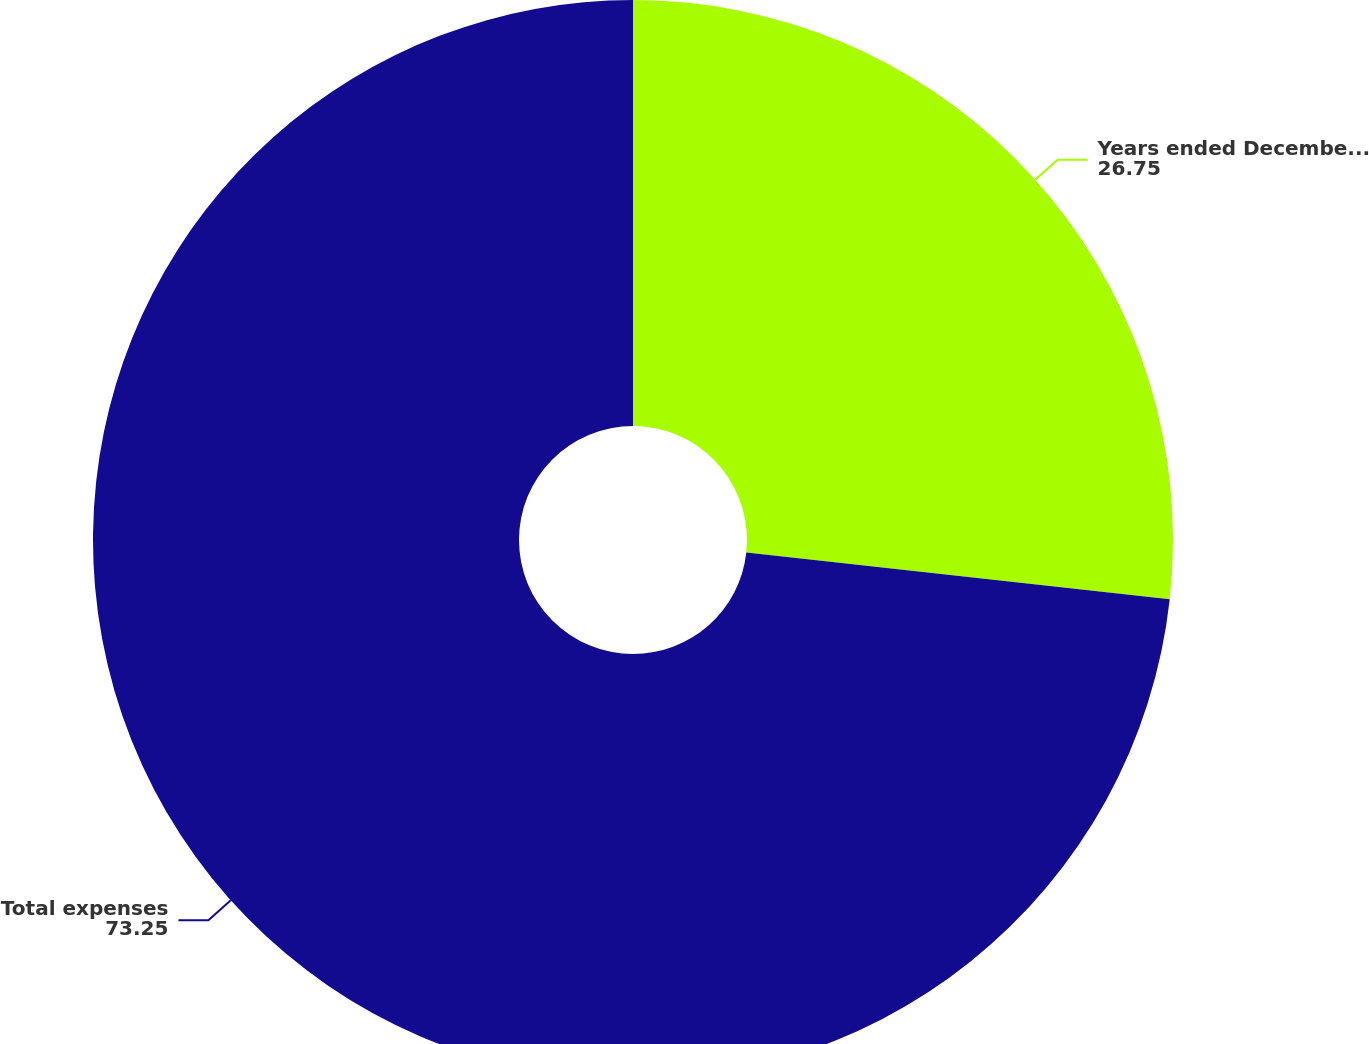Convert chart to OTSL. <chart><loc_0><loc_0><loc_500><loc_500><pie_chart><fcel>Years ended December 31<fcel>Total expenses<nl><fcel>26.75%<fcel>73.25%<nl></chart> 